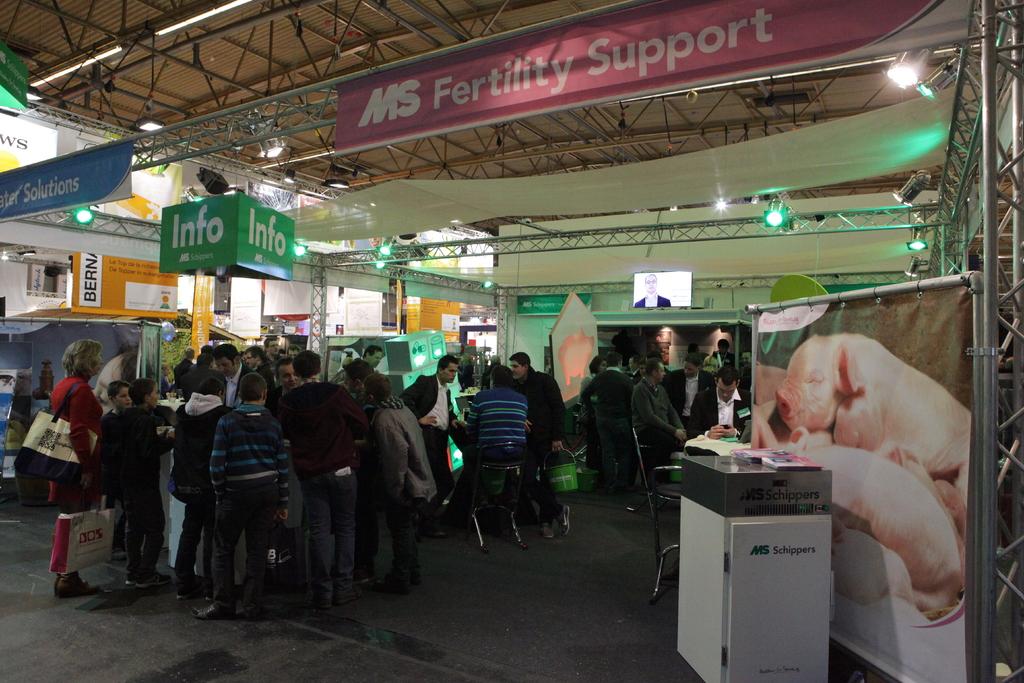What kind of support?
Offer a very short reply. Fertility. 